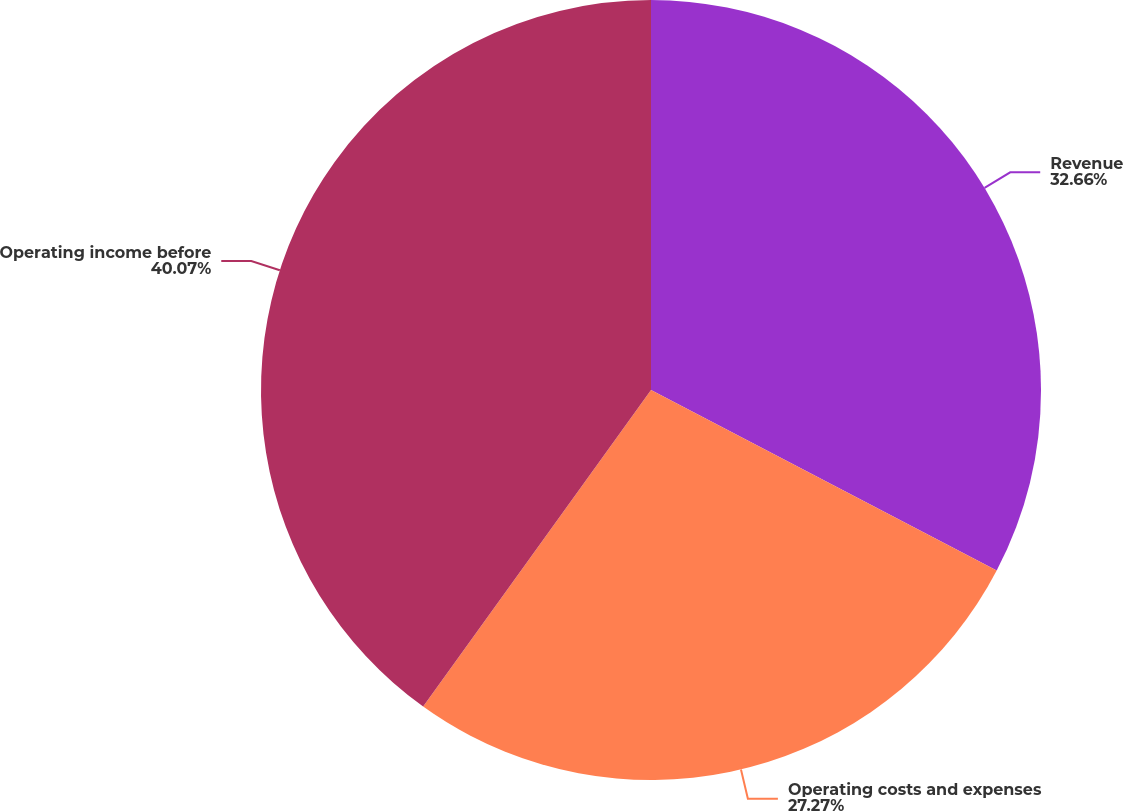Convert chart to OTSL. <chart><loc_0><loc_0><loc_500><loc_500><pie_chart><fcel>Revenue<fcel>Operating costs and expenses<fcel>Operating income before<nl><fcel>32.66%<fcel>27.27%<fcel>40.07%<nl></chart> 